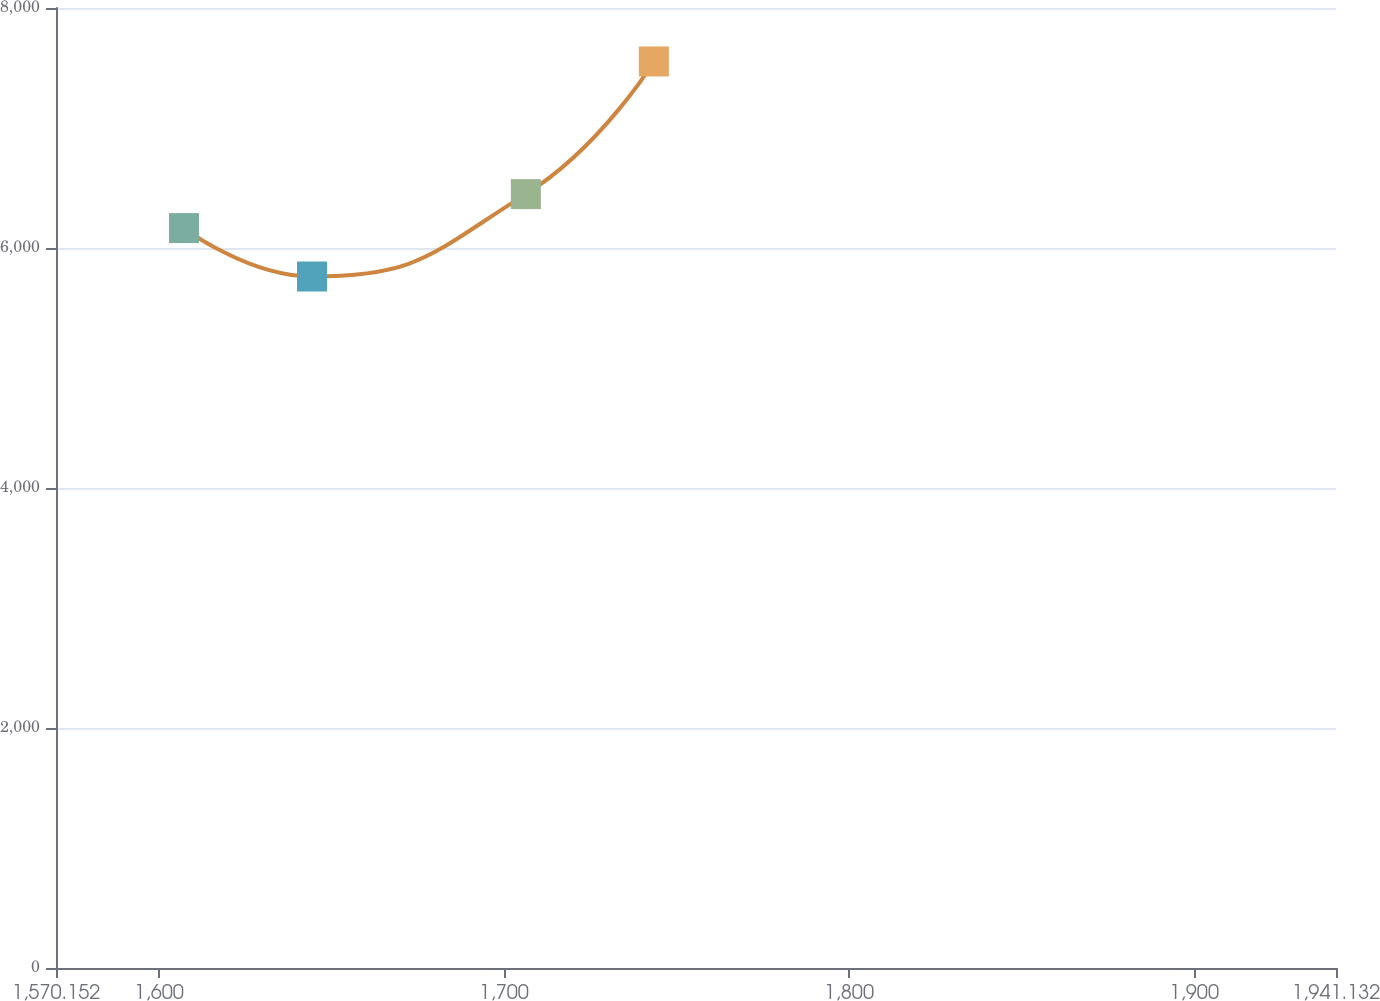Convert chart to OTSL. <chart><loc_0><loc_0><loc_500><loc_500><line_chart><ecel><fcel>Unnamed: 1<nl><fcel>1607.25<fcel>6165.92<nl><fcel>1644.35<fcel>5762.41<nl><fcel>1706.33<fcel>6448.9<nl><fcel>1743.43<fcel>7554.56<nl><fcel>1978.23<fcel>8592.2<nl></chart> 